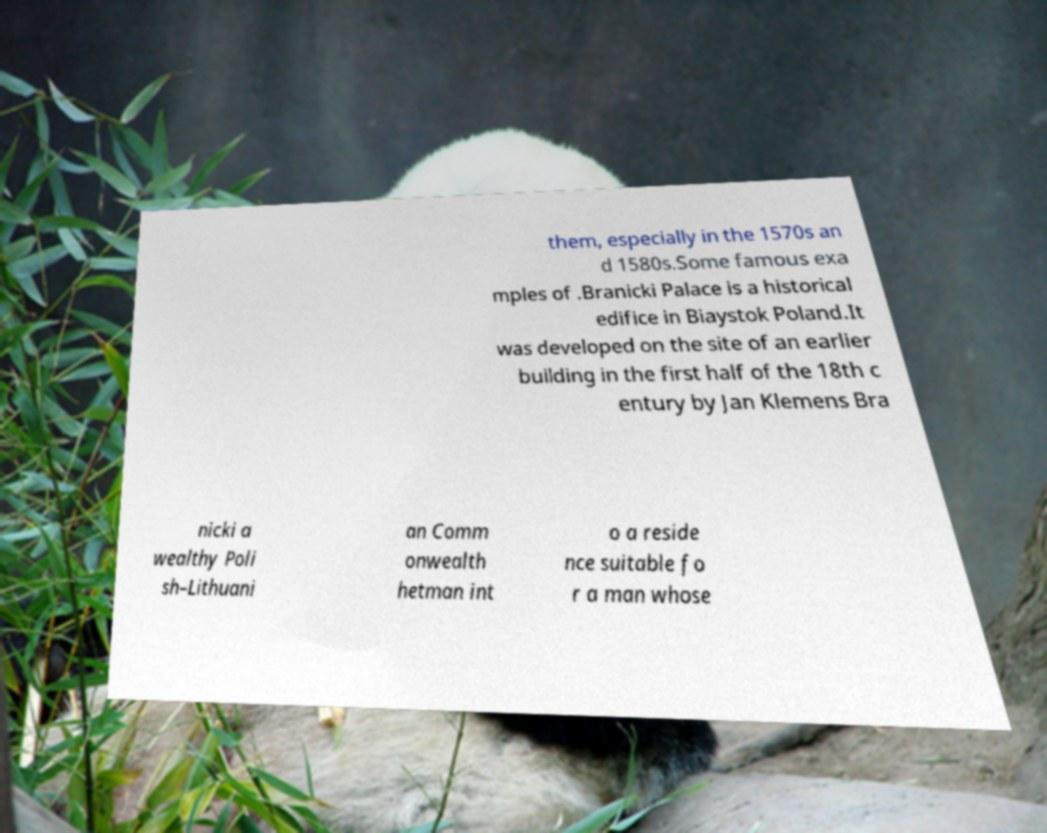Can you accurately transcribe the text from the provided image for me? them, especially in the 1570s an d 1580s.Some famous exa mples of .Branicki Palace is a historical edifice in Biaystok Poland.It was developed on the site of an earlier building in the first half of the 18th c entury by Jan Klemens Bra nicki a wealthy Poli sh–Lithuani an Comm onwealth hetman int o a reside nce suitable fo r a man whose 